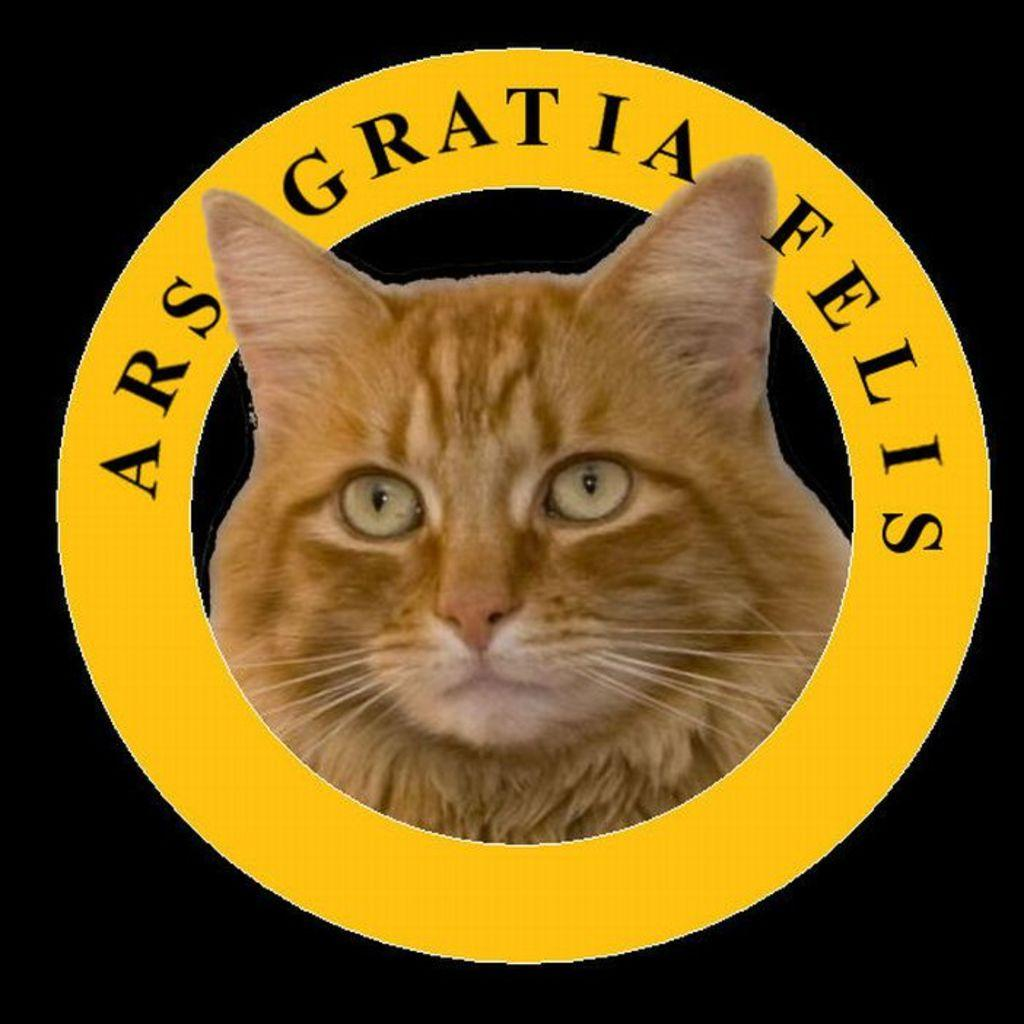What is the main subject of the image? The main subject of the image is a cat face. Can you describe the colors of the cat face? The cat face is cream and brown in color. What else is present in the image besides the cat face? There are words written in the image. How would you describe the background of the image? The background of the image is dark. How many arches can be seen supporting the cat face in the image? There are no arches present in the image; it features a cat face with a dark background and words written on it. What type of boot is the cat wearing in the image? There is no cat wearing a boot in the image; it is a cat face with a dark background and words written on it. 